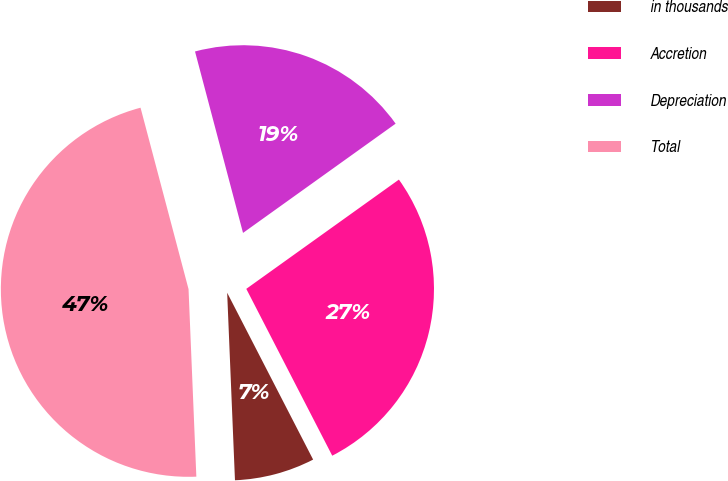Convert chart to OTSL. <chart><loc_0><loc_0><loc_500><loc_500><pie_chart><fcel>in thousands<fcel>Accretion<fcel>Depreciation<fcel>Total<nl><fcel>6.91%<fcel>27.32%<fcel>19.23%<fcel>46.55%<nl></chart> 